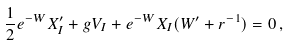Convert formula to latex. <formula><loc_0><loc_0><loc_500><loc_500>\frac { 1 } { 2 } e ^ { - W } X _ { I } ^ { \prime } + g V _ { I } + e ^ { - W } X _ { I } ( W ^ { \prime } + r ^ { - 1 } ) = 0 \, ,</formula> 